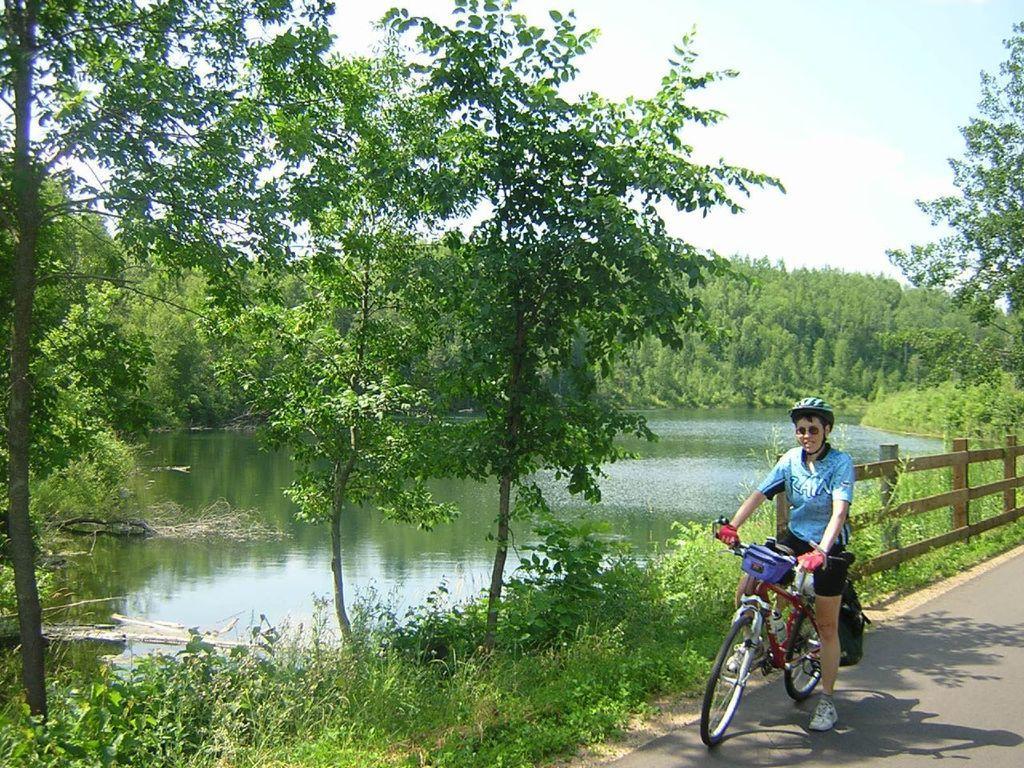Please provide a concise description of this image. In this image I see person who is on the cycle and the person is on the path. In the background I see the plants, trees, water and the sky. 